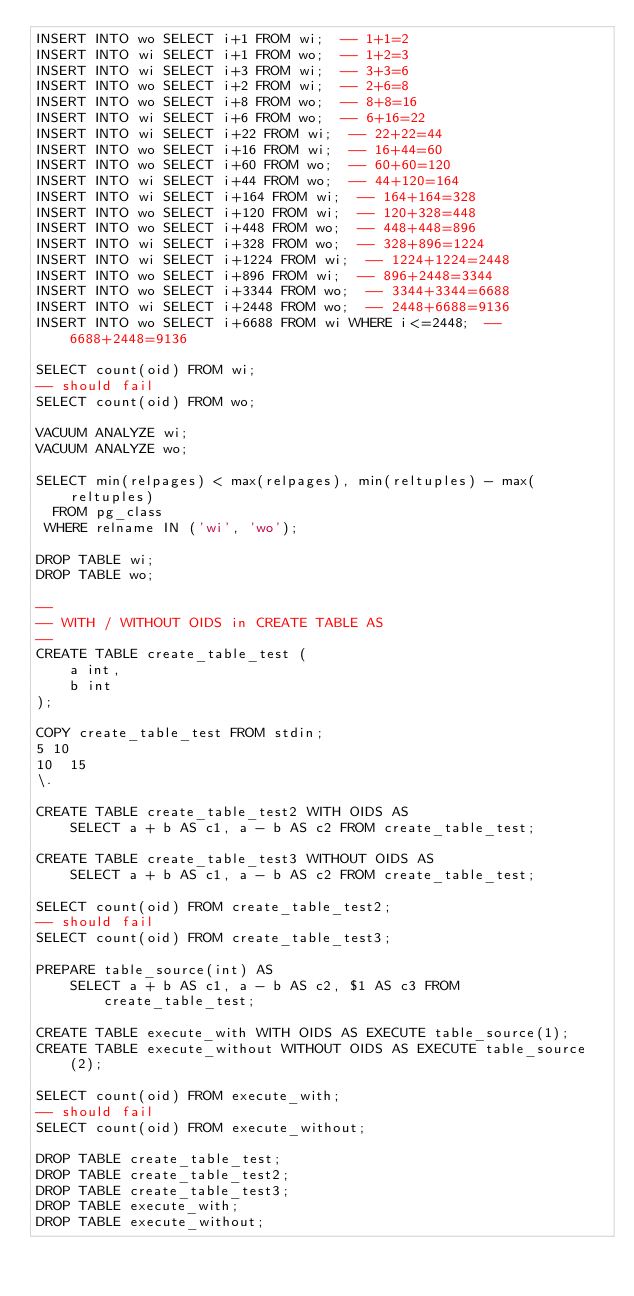<code> <loc_0><loc_0><loc_500><loc_500><_SQL_>INSERT INTO wo SELECT i+1 FROM wi;  -- 1+1=2
INSERT INTO wi SELECT i+1 FROM wo;  -- 1+2=3
INSERT INTO wi SELECT i+3 FROM wi;  -- 3+3=6
INSERT INTO wo SELECT i+2 FROM wi;  -- 2+6=8
INSERT INTO wo SELECT i+8 FROM wo;  -- 8+8=16
INSERT INTO wi SELECT i+6 FROM wo;  -- 6+16=22
INSERT INTO wi SELECT i+22 FROM wi;  -- 22+22=44
INSERT INTO wo SELECT i+16 FROM wi;  -- 16+44=60
INSERT INTO wo SELECT i+60 FROM wo;  -- 60+60=120
INSERT INTO wi SELECT i+44 FROM wo;  -- 44+120=164
INSERT INTO wi SELECT i+164 FROM wi;  -- 164+164=328
INSERT INTO wo SELECT i+120 FROM wi;  -- 120+328=448
INSERT INTO wo SELECT i+448 FROM wo;  -- 448+448=896
INSERT INTO wi SELECT i+328 FROM wo;  -- 328+896=1224
INSERT INTO wi SELECT i+1224 FROM wi;  -- 1224+1224=2448
INSERT INTO wo SELECT i+896 FROM wi;  -- 896+2448=3344
INSERT INTO wo SELECT i+3344 FROM wo;  -- 3344+3344=6688
INSERT INTO wi SELECT i+2448 FROM wo;  -- 2448+6688=9136
INSERT INTO wo SELECT i+6688 FROM wi WHERE i<=2448;  -- 6688+2448=9136

SELECT count(oid) FROM wi;
-- should fail
SELECT count(oid) FROM wo;

VACUUM ANALYZE wi;
VACUUM ANALYZE wo;

SELECT min(relpages) < max(relpages), min(reltuples) - max(reltuples)
  FROM pg_class
 WHERE relname IN ('wi', 'wo');

DROP TABLE wi;
DROP TABLE wo;

--
-- WITH / WITHOUT OIDS in CREATE TABLE AS
--
CREATE TABLE create_table_test (
    a int,
    b int
);

COPY create_table_test FROM stdin;
5	10
10	15
\.

CREATE TABLE create_table_test2 WITH OIDS AS
    SELECT a + b AS c1, a - b AS c2 FROM create_table_test;

CREATE TABLE create_table_test3 WITHOUT OIDS AS
    SELECT a + b AS c1, a - b AS c2 FROM create_table_test;

SELECT count(oid) FROM create_table_test2;
-- should fail
SELECT count(oid) FROM create_table_test3;

PREPARE table_source(int) AS
    SELECT a + b AS c1, a - b AS c2, $1 AS c3 FROM create_table_test;

CREATE TABLE execute_with WITH OIDS AS EXECUTE table_source(1);
CREATE TABLE execute_without WITHOUT OIDS AS EXECUTE table_source(2);

SELECT count(oid) FROM execute_with;
-- should fail
SELECT count(oid) FROM execute_without;

DROP TABLE create_table_test;
DROP TABLE create_table_test2;
DROP TABLE create_table_test3;
DROP TABLE execute_with;
DROP TABLE execute_without;
</code> 